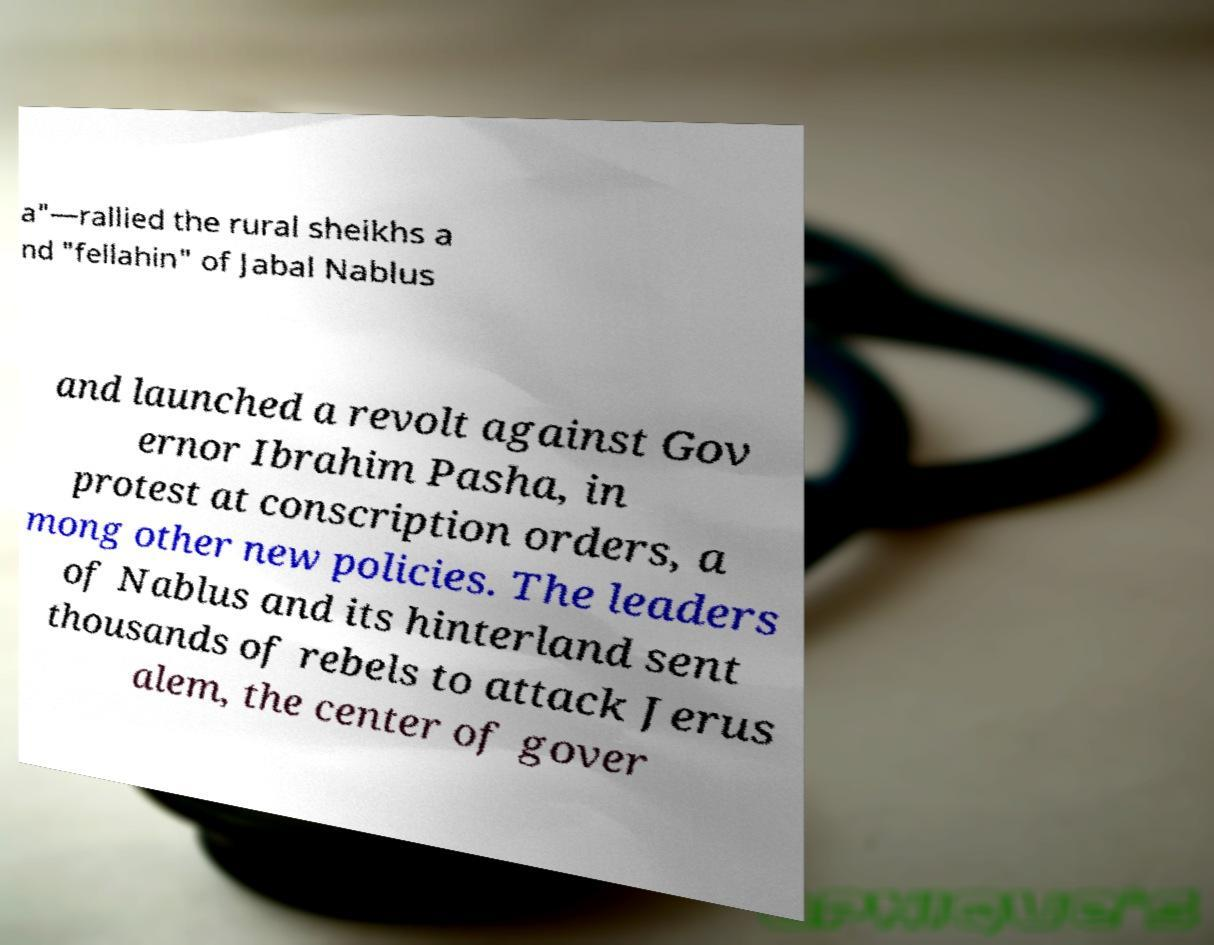What messages or text are displayed in this image? I need them in a readable, typed format. a"—rallied the rural sheikhs a nd "fellahin" of Jabal Nablus and launched a revolt against Gov ernor Ibrahim Pasha, in protest at conscription orders, a mong other new policies. The leaders of Nablus and its hinterland sent thousands of rebels to attack Jerus alem, the center of gover 